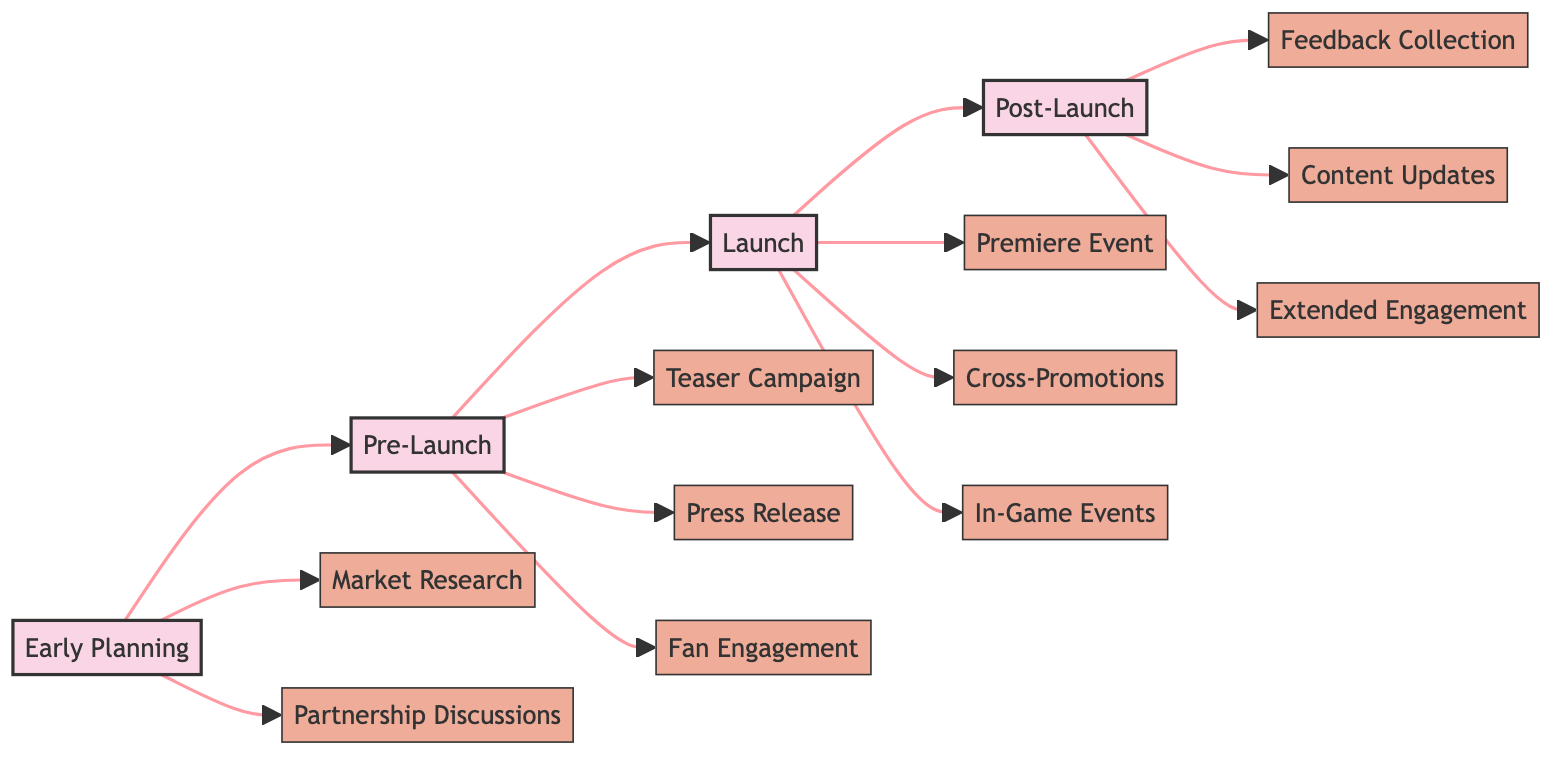What is the first phase in the marketing strategy timeline? The first phase listed in the diagram is "Early Planning." It is positioned at the start of the flowchart, indicating it is the initial stage of the marketing strategy.
Answer: Early Planning How many activities are involved in the Pre-Launch phase? In the diagram, there are three activities listed under the "Pre-Launch" phase: Teaser Campaign, Press Release, and Fan Engagement. This can be counted directly from the diagram.
Answer: Three Which activity comes directly after the Launch phase? The diagram shows that after the "Launch" phase, it goes directly to the "Post-Launch" phase. By observing the flow direction in the diagram, we can determine this relationship.
Answer: Post-Launch Name one of the activities included in the Launch phase. The Launch phase includes several activities. One of them as shown in the diagram is "Premiere Event." This can be found in the activities connected to the Launch phase node.
Answer: Premiere Event What relationship does "Market Research" have with "Partnership Discussions"? "Market Research" and "Partnership Discussions" are both activities listed under the "Early Planning" phase. The diagram shows they are parallel to each other, meaning they are independent activities occurring during the same phase.
Answer: Parallel activities What follows "Teaser Campaign" in the marketing strategy timeline? According to the diagram, "Teaser Campaign" is followed by "Press Release" and then "Fan Engagement" in the Pre-Launch phase. This indicates the sequence of activities as they flow through the Pre-Launch phase.
Answer: Press Release How many total phases are depicted in the diagram? The diagram contains four phases: Early Planning, Pre-Launch, Launch, and Post-Launch. This total can be counted from the flowchart nodes.
Answer: Four Which phase includes "Feedback Collection" as an activity? The activity "Feedback Collection" is part of the "Post-Launch" phase, as indicated by the flowchart that connects it to that specific phase.
Answer: Post-Launch What type of engagement is planned for after the Post-Launch phase? The diagram indicates "Extended Engagement" as an activity planned for after the Post-Launch phase, suggesting ongoing interaction with the audience based on the movie's performance.
Answer: Extended Engagement 